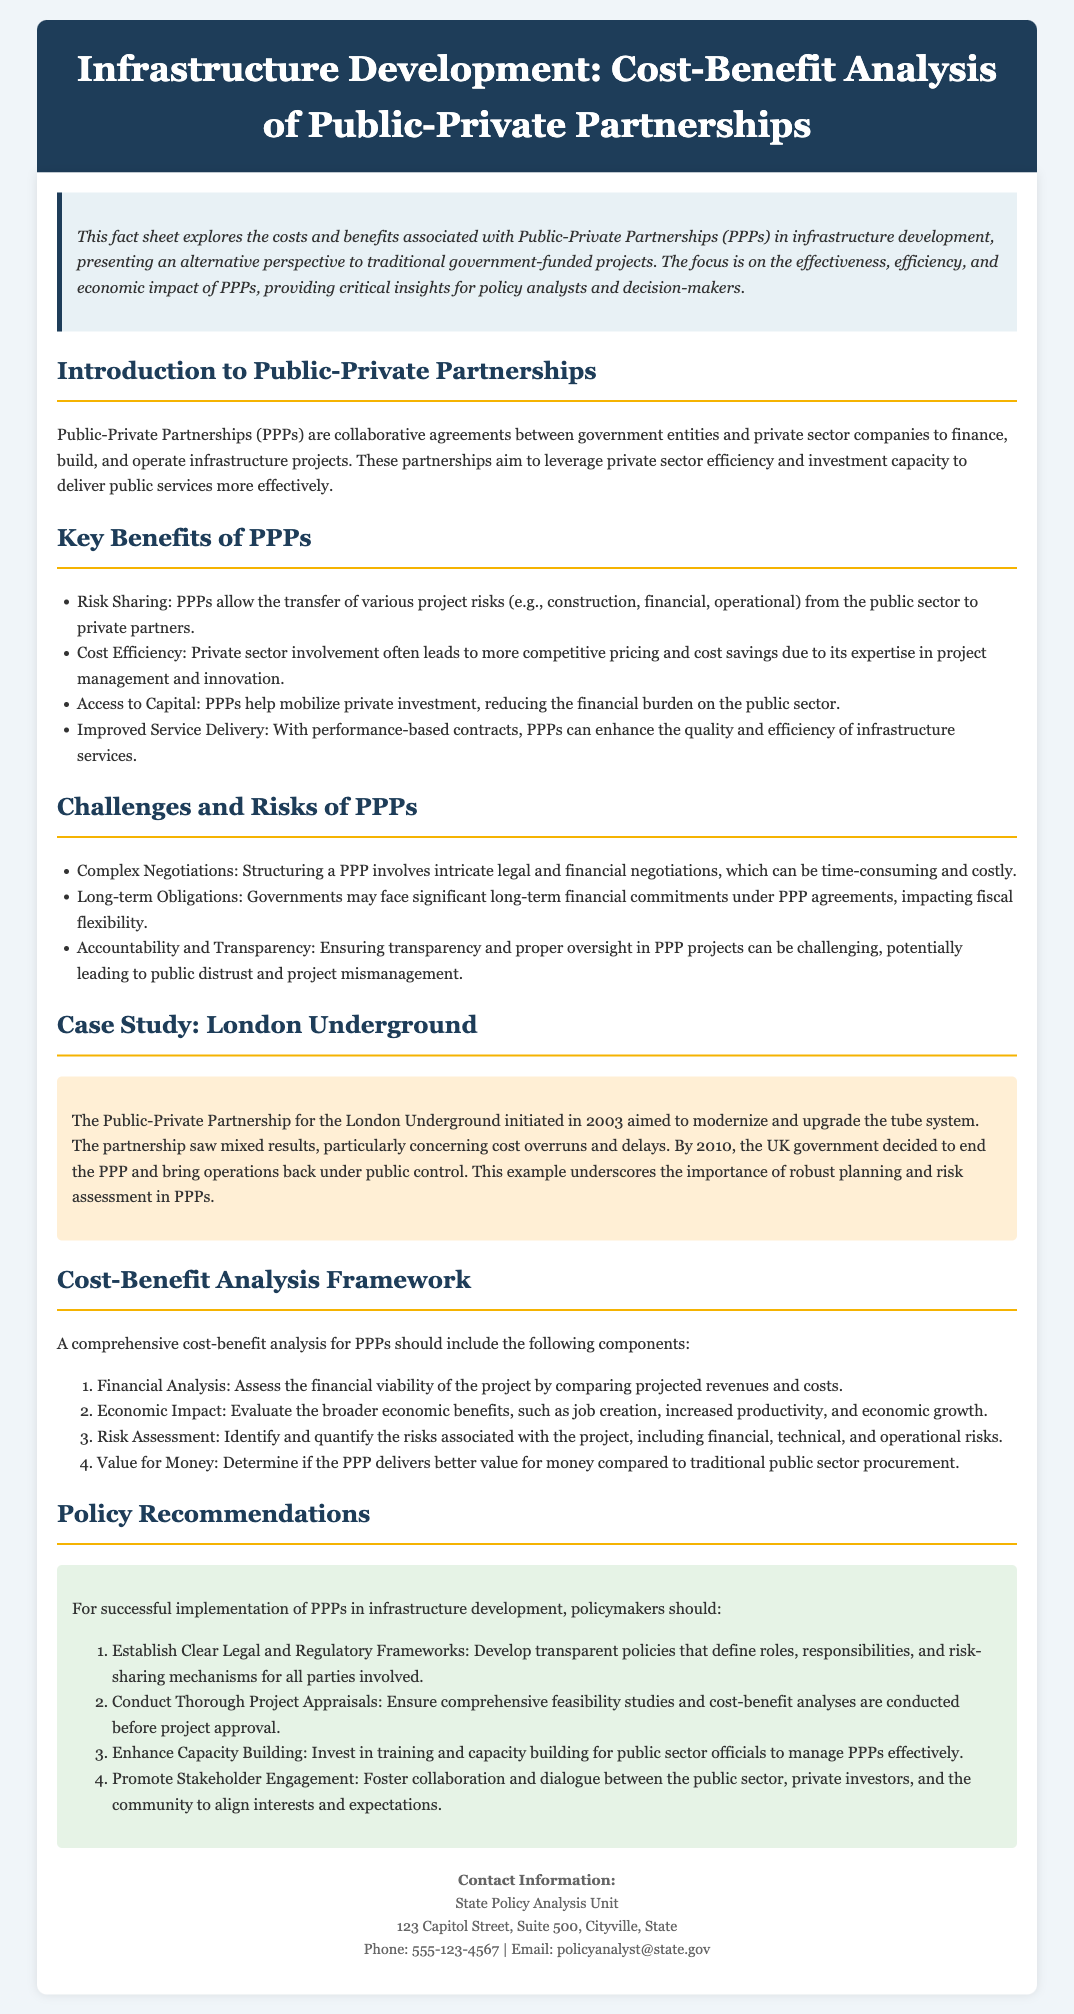What are Public-Private Partnerships? Public-Private Partnerships are collaborative agreements between government entities and private sector companies to finance, build, and operate infrastructure projects.
Answer: Collaborative agreements What is a key benefit of PPPs in terms of risk? One of the key benefits of PPPs is risk sharing, allowing for the transfer of project risks from the public sector to private partners.
Answer: Risk sharing What year did the London Underground PPP initiate? The London Underground Public-Private Partnership initiated in 2003.
Answer: 2003 What should a comprehensive cost-benefit analysis for PPPs include? A comprehensive cost-benefit analysis should include financial analysis, economic impact, risk assessment, and value for money.
Answer: Financial analysis, economic impact, risk assessment, value for money What is one recommended policy for the successful implementation of PPPs? One recommended policy for successful PPP implementation is to establish clear legal and regulatory frameworks.
Answer: Clear legal and regulatory frameworks What is the main challenge mentioned about PPPs? One main challenge of PPPs is complex negotiations.
Answer: Complex negotiations How does private sector involvement benefit service delivery? Private sector involvement can improve service delivery through performance-based contracts.
Answer: Performance-based contracts What is the email for contact regarding the Fact Sheet? The email for contact is provided as policyanalyst@state.gov.
Answer: policyanalyst@state.gov 